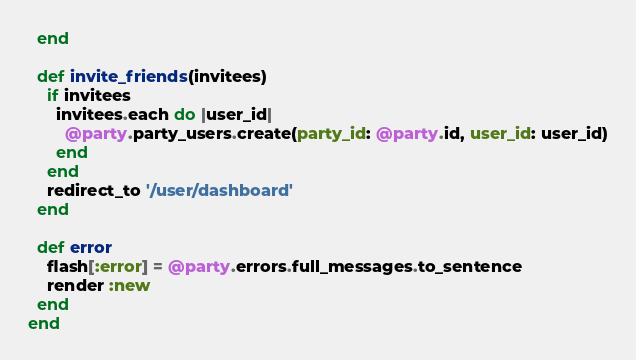<code> <loc_0><loc_0><loc_500><loc_500><_Ruby_>  end

  def invite_friends(invitees)
    if invitees
      invitees.each do |user_id|
        @party.party_users.create(party_id: @party.id, user_id: user_id)
      end
    end
    redirect_to '/user/dashboard'
  end

  def error
    flash[:error] = @party.errors.full_messages.to_sentence
    render :new
  end
end
</code> 